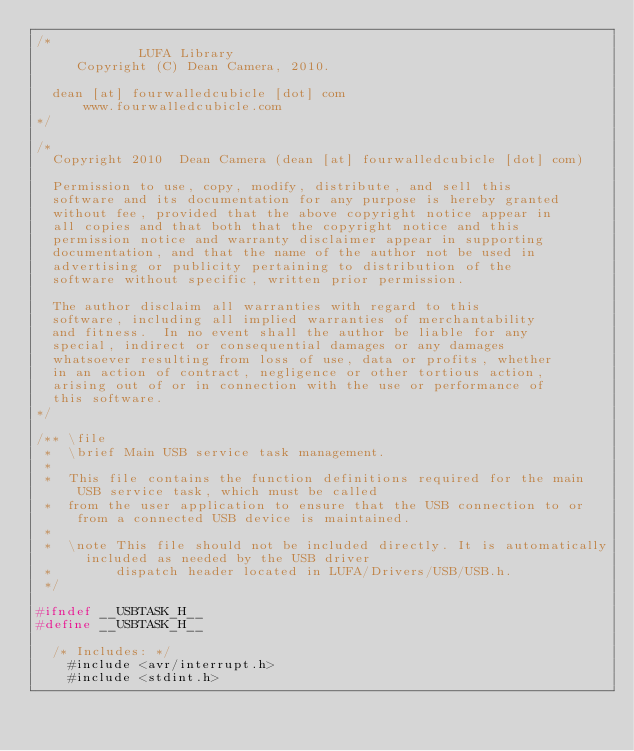Convert code to text. <code><loc_0><loc_0><loc_500><loc_500><_C_>/*
             LUFA Library
     Copyright (C) Dean Camera, 2010.
              
  dean [at] fourwalledcubicle [dot] com
      www.fourwalledcubicle.com
*/

/*
  Copyright 2010  Dean Camera (dean [at] fourwalledcubicle [dot] com)

  Permission to use, copy, modify, distribute, and sell this 
  software and its documentation for any purpose is hereby granted
  without fee, provided that the above copyright notice appear in 
  all copies and that both that the copyright notice and this
  permission notice and warranty disclaimer appear in supporting 
  documentation, and that the name of the author not be used in 
  advertising or publicity pertaining to distribution of the 
  software without specific, written prior permission.

  The author disclaim all warranties with regard to this
  software, including all implied warranties of merchantability
  and fitness.  In no event shall the author be liable for any
  special, indirect or consequential damages or any damages
  whatsoever resulting from loss of use, data or profits, whether
  in an action of contract, negligence or other tortious action,
  arising out of or in connection with the use or performance of
  this software.
*/

/** \file
 *  \brief Main USB service task management.
 *
 *  This file contains the function definitions required for the main USB service task, which must be called
 *  from the user application to ensure that the USB connection to or from a connected USB device is maintained.
 *
 *  \note This file should not be included directly. It is automatically included as needed by the USB driver
 *        dispatch header located in LUFA/Drivers/USB/USB.h.
 */

#ifndef __USBTASK_H__
#define __USBTASK_H__

	/* Includes: */
		#include <avr/interrupt.h>
		#include <stdint.h></code> 